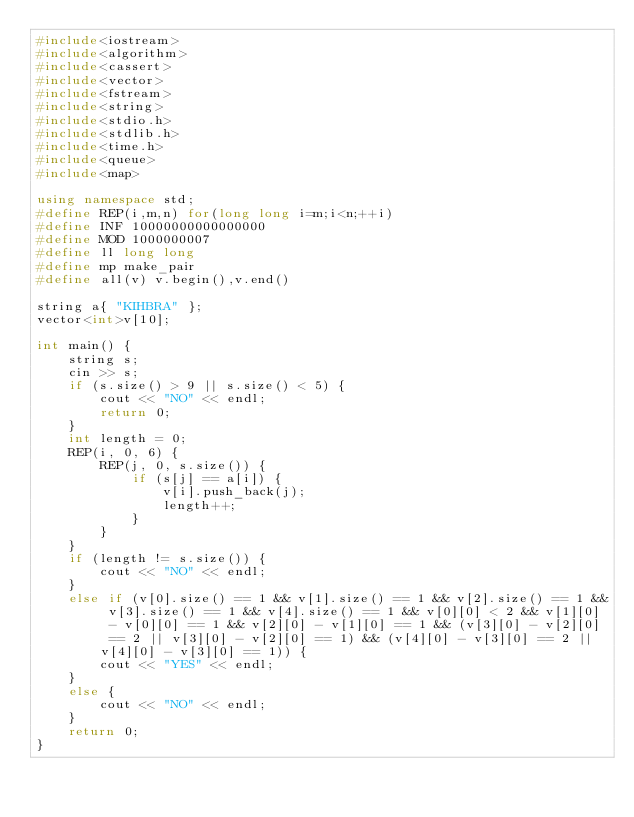<code> <loc_0><loc_0><loc_500><loc_500><_C++_>#include<iostream>
#include<algorithm>
#include<cassert>
#include<vector>
#include<fstream>
#include<string>
#include<stdio.h>
#include<stdlib.h>
#include<time.h>
#include<queue>
#include<map>

using namespace std;
#define REP(i,m,n) for(long long i=m;i<n;++i)
#define INF 10000000000000000
#define MOD 1000000007
#define ll long long
#define mp make_pair
#define all(v) v.begin(),v.end()

string a{ "KIHBRA" };
vector<int>v[10];

int main() {
	string s;
	cin >> s;
	if (s.size() > 9 || s.size() < 5) {
		cout << "NO" << endl;
		return 0;
	}
	int length = 0;
	REP(i, 0, 6) {
		REP(j, 0, s.size()) {
			if (s[j] == a[i]) {
				v[i].push_back(j);
				length++;
			}
		}
	}
	if (length != s.size()) {
		cout << "NO" << endl;
	}
	else if (v[0].size() == 1 && v[1].size() == 1 && v[2].size() == 1 && v[3].size() == 1 && v[4].size() == 1 && v[0][0] < 2 && v[1][0] - v[0][0] == 1 && v[2][0] - v[1][0] == 1 && (v[3][0] - v[2][0] == 2 || v[3][0] - v[2][0] == 1) && (v[4][0] - v[3][0] == 2 || v[4][0] - v[3][0] == 1)) {
		cout << "YES" << endl;
	}
	else {
		cout << "NO" << endl;
	}
	return 0;
}</code> 